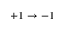Convert formula to latex. <formula><loc_0><loc_0><loc_500><loc_500>+ 1 \rightarrow - 1</formula> 